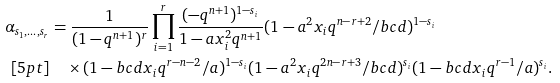Convert formula to latex. <formula><loc_0><loc_0><loc_500><loc_500>\alpha _ { s _ { 1 } , \dots , s _ { r } } & = \frac { 1 } { ( 1 - q ^ { n + 1 } ) ^ { r } } \prod _ { i = 1 } ^ { r } \frac { ( - q ^ { n + 1 } ) ^ { 1 - s _ { i } } } { 1 - a x _ { i } ^ { 2 } q ^ { n + 1 } } ( 1 - a ^ { 2 } x _ { i } q ^ { n - r + 2 } / b c d ) ^ { 1 - s _ { i } } \\ [ 5 p t ] & \quad \times ( 1 - b c d x _ { i } q ^ { r - n - 2 } / a ) ^ { 1 - s _ { i } } ( 1 - a ^ { 2 } x _ { i } q ^ { 2 n - r + 3 } / b c d ) ^ { s _ { i } } ( 1 - b c d x _ { i } q ^ { r - 1 } / a ) ^ { s _ { i } } .</formula> 